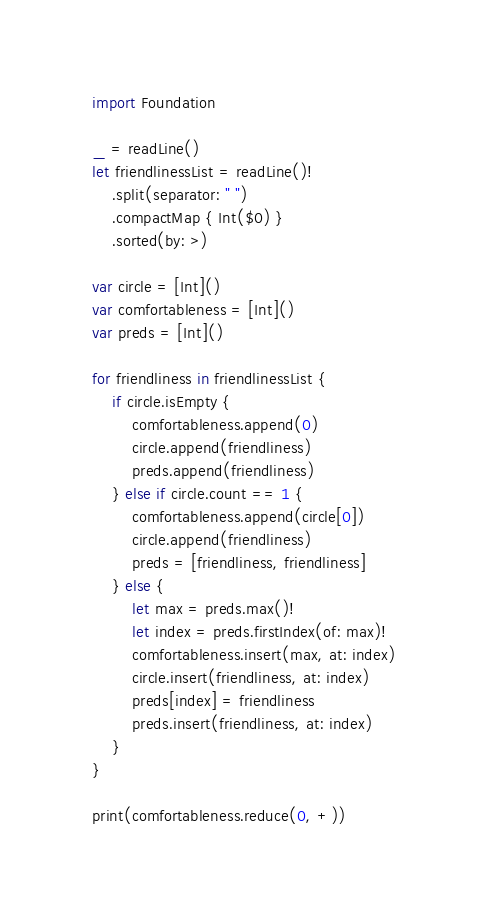Convert code to text. <code><loc_0><loc_0><loc_500><loc_500><_Swift_>import Foundation

_ = readLine()
let friendlinessList = readLine()!
    .split(separator: " ")
    .compactMap { Int($0) }
    .sorted(by: >)

var circle = [Int]()
var comfortableness = [Int]()
var preds = [Int]()

for friendliness in friendlinessList {
    if circle.isEmpty {
        comfortableness.append(0)
        circle.append(friendliness)
        preds.append(friendliness)
    } else if circle.count == 1 {
        comfortableness.append(circle[0])
        circle.append(friendliness)
        preds = [friendliness, friendliness]
    } else {
        let max = preds.max()!
        let index = preds.firstIndex(of: max)!
        comfortableness.insert(max, at: index)
        circle.insert(friendliness, at: index)
        preds[index] = friendliness
        preds.insert(friendliness, at: index)
    }
}

print(comfortableness.reduce(0, +))
</code> 